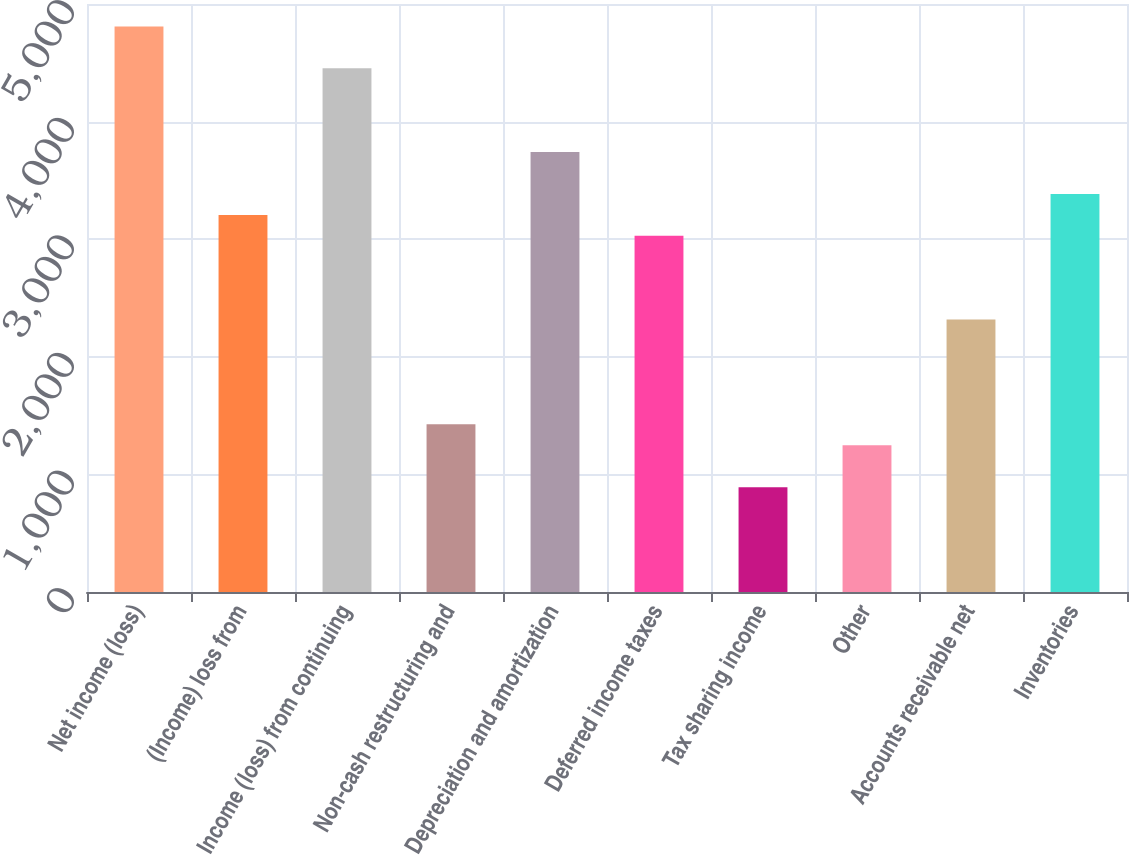Convert chart. <chart><loc_0><loc_0><loc_500><loc_500><bar_chart><fcel>Net income (loss)<fcel>(Income) loss from<fcel>Income (loss) from continuing<fcel>Non-cash restructuring and<fcel>Depreciation and amortization<fcel>Deferred income taxes<fcel>Tax sharing income<fcel>Other<fcel>Accounts receivable net<fcel>Inventories<nl><fcel>4809.7<fcel>3206.8<fcel>4453.5<fcel>1425.8<fcel>3741.1<fcel>3028.7<fcel>891.5<fcel>1247.7<fcel>2316.3<fcel>3384.9<nl></chart> 